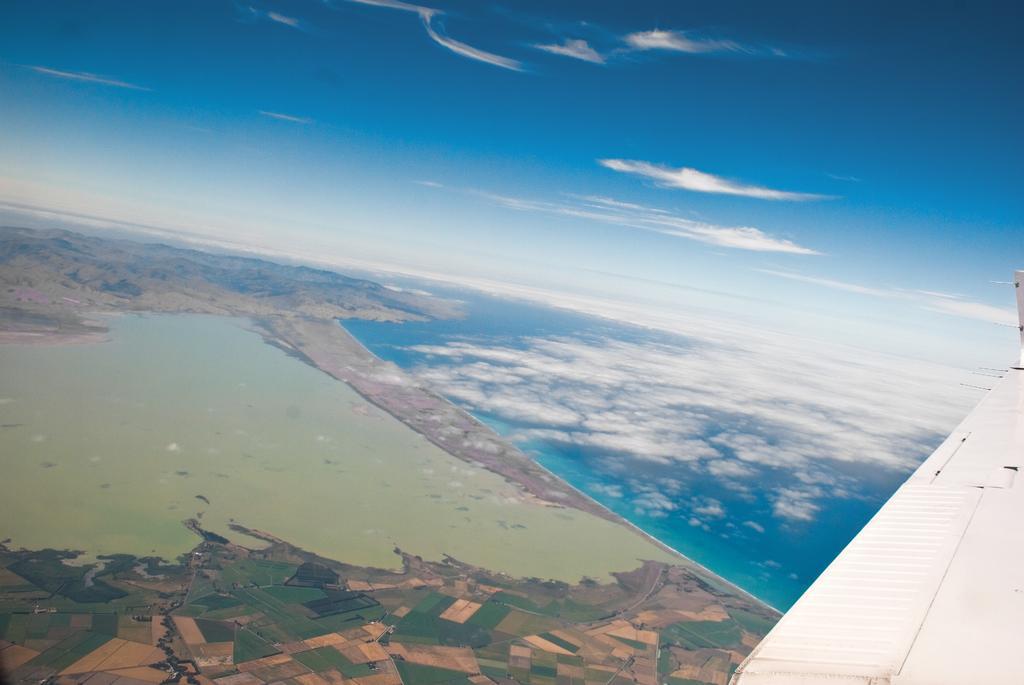How would you summarize this image in a sentence or two? In this picture we can see an airplane wing. On the left side of the wing there are fields, water and a sky. 